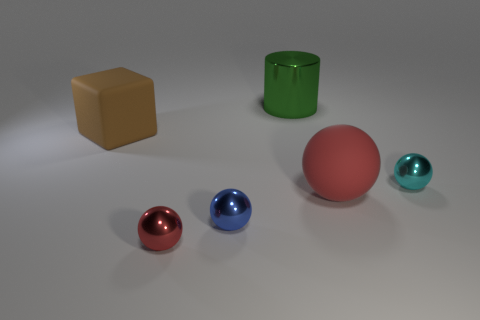Add 2 blue spheres. How many objects exist? 8 Subtract all cylinders. How many objects are left? 5 Add 3 blue spheres. How many blue spheres exist? 4 Subtract 0 yellow balls. How many objects are left? 6 Subtract all small objects. Subtract all large cubes. How many objects are left? 2 Add 6 large objects. How many large objects are left? 9 